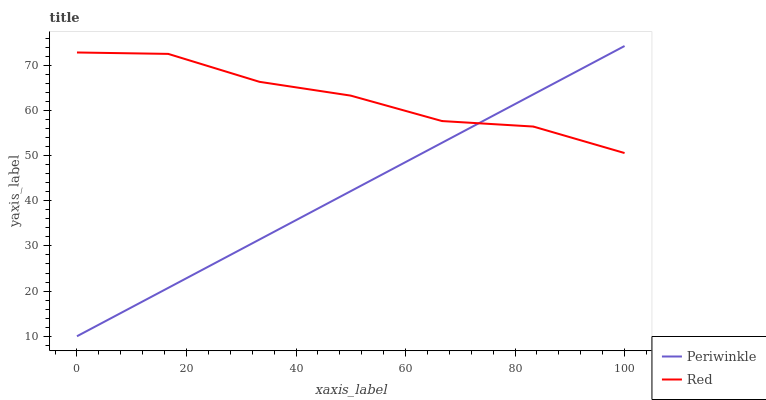Does Periwinkle have the minimum area under the curve?
Answer yes or no. Yes. Does Red have the maximum area under the curve?
Answer yes or no. Yes. Does Red have the minimum area under the curve?
Answer yes or no. No. Is Periwinkle the smoothest?
Answer yes or no. Yes. Is Red the roughest?
Answer yes or no. Yes. Is Red the smoothest?
Answer yes or no. No. Does Red have the lowest value?
Answer yes or no. No. Does Periwinkle have the highest value?
Answer yes or no. Yes. Does Red have the highest value?
Answer yes or no. No. Does Red intersect Periwinkle?
Answer yes or no. Yes. Is Red less than Periwinkle?
Answer yes or no. No. Is Red greater than Periwinkle?
Answer yes or no. No. 